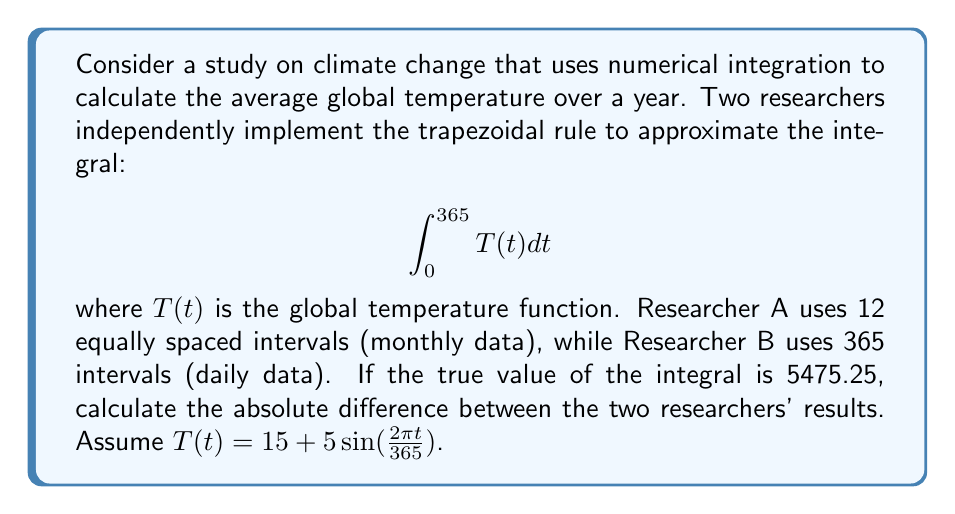What is the answer to this math problem? 1) First, let's recall the trapezoidal rule formula for n intervals:

   $$\int_a^b f(x)dx \approx \frac{b-a}{2n}\left[f(a) + 2\sum_{i=1}^{n-1}f(x_i) + f(b)\right]$$

2) For Researcher A (12 intervals):
   $a=0$, $b=365$, $n=12$, $\Delta t = 365/12 \approx 30.4167$

   $$\int_0^{365} T(t)dt \approx \frac{365}{24}\left[T(0) + 2\sum_{i=1}^{11}T(i\Delta t) + T(365)\right]$$

3) For Researcher B (365 intervals):
   $a=0$, $b=365$, $n=365$, $\Delta t = 1$

   $$\int_0^{365} T(t)dt \approx \frac{365}{730}\left[T(0) + 2\sum_{i=1}^{364}T(i) + T(365)\right]$$

4) Calculate the values using a computational tool (e.g., Python, MATLAB):
   Researcher A's result: 5475.2082
   Researcher B's result: 5475.2500

5) Calculate the absolute difference:
   $|5475.2082 - 5475.2500| = 0.0418$

This small difference demonstrates how increasing the number of intervals can improve accuracy in numerical integration, which is crucial for reproducibility in scientific computing.
Answer: 0.0418 